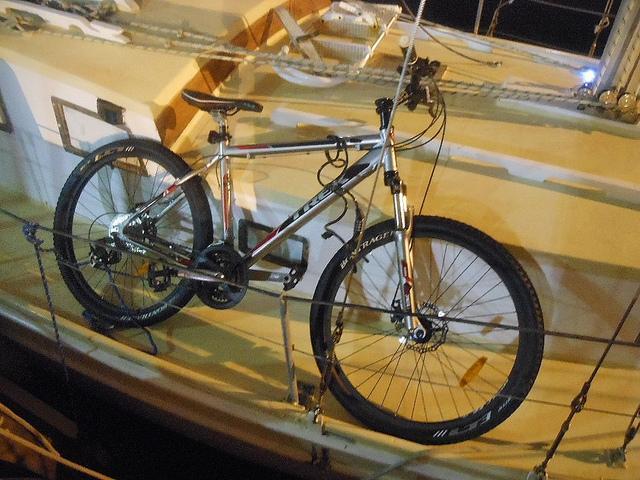Is "The bicycle is on the boat." an appropriate description for the image?
Answer yes or no. Yes. 